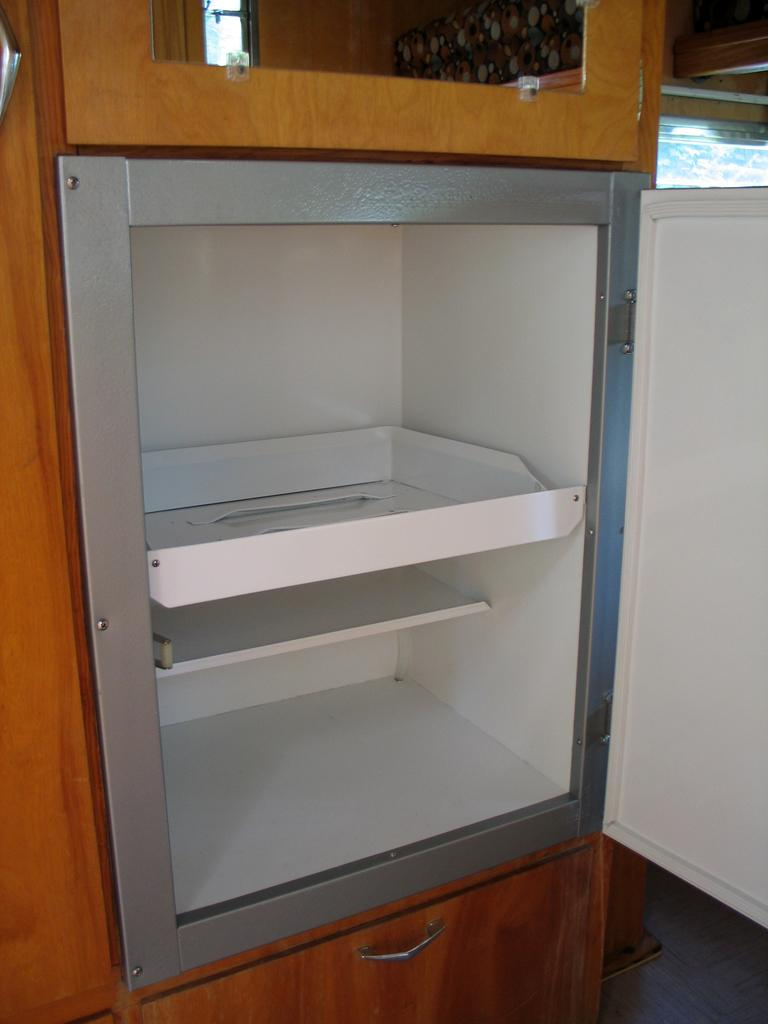What type of furniture is visible in the image? There are trays in a cupboard in the image. What other architectural feature can be seen in the image? There are doors in the image. What type of gold object is hanging from the doors in the image? There is no gold object present in the image, and therefore no such object can be observed hanging from the doors. What time of day is it in the image, given the presence of a quill? There is no quill present in the image, so it cannot be determined from the picture. 